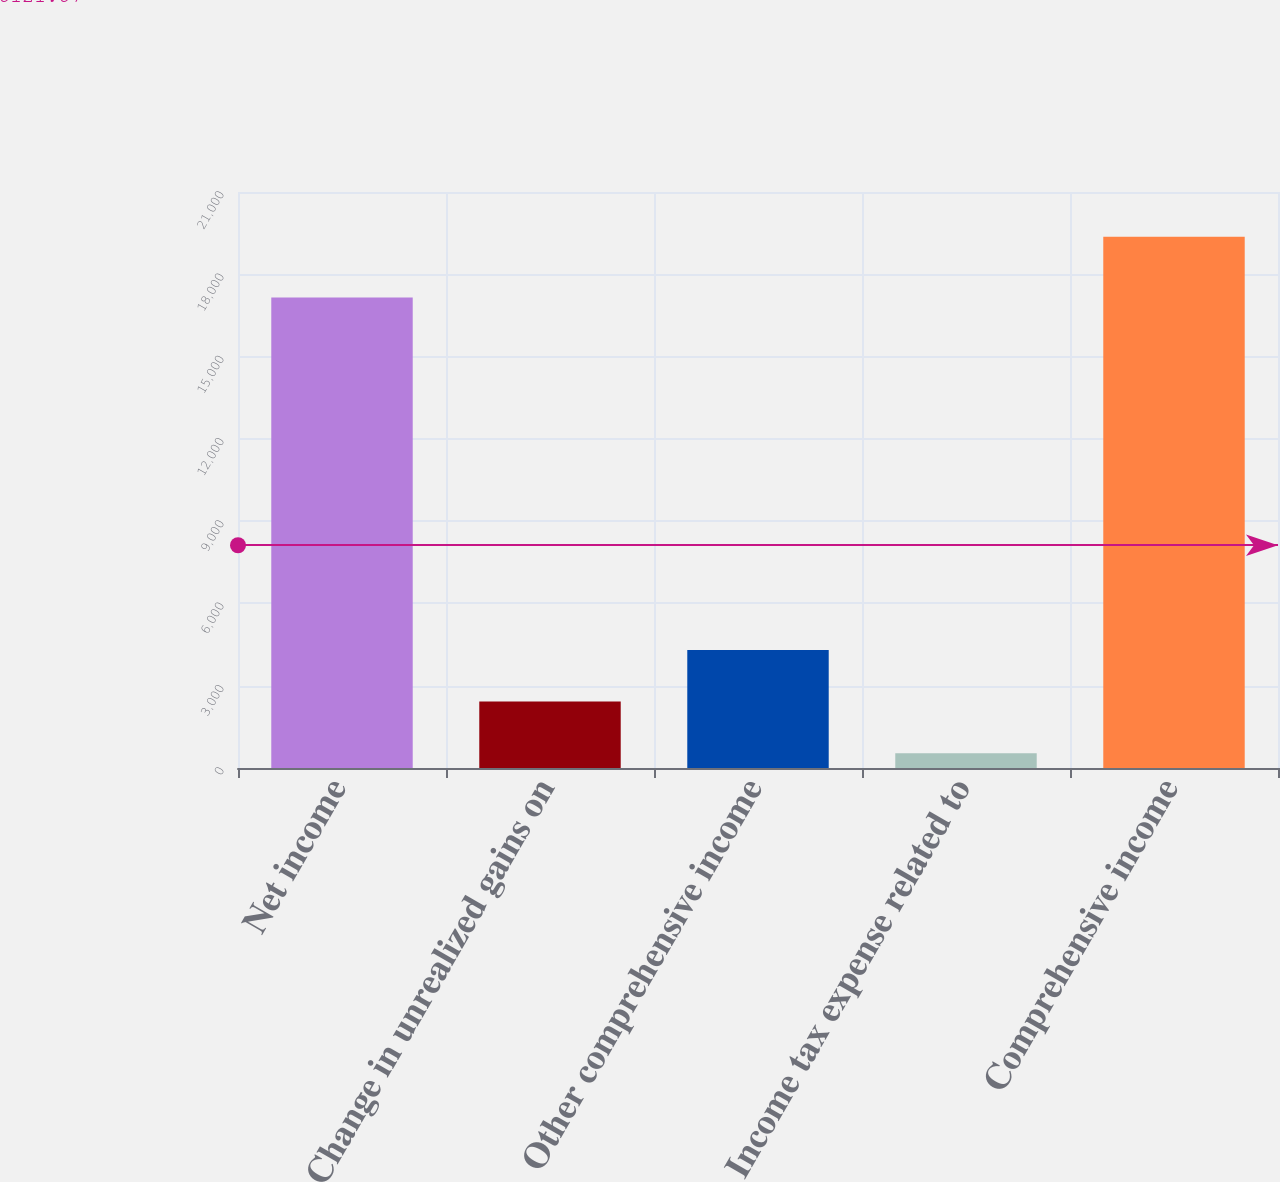<chart> <loc_0><loc_0><loc_500><loc_500><bar_chart><fcel>Net income<fcel>Change in unrealized gains on<fcel>Other comprehensive income<fcel>Income tax expense related to<fcel>Comprehensive income<nl><fcel>17152<fcel>2420.7<fcel>4303.4<fcel>538<fcel>19365<nl></chart> 